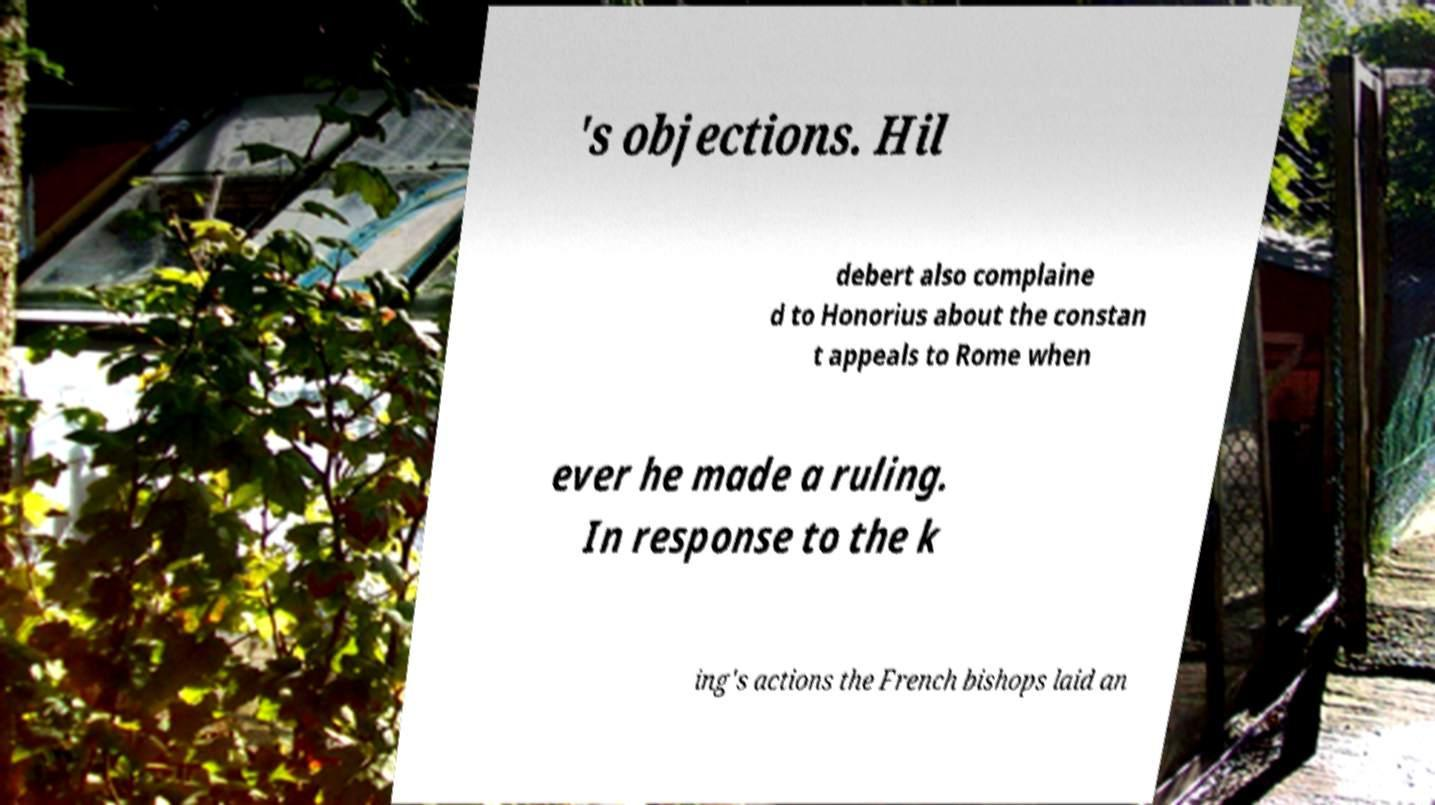Please identify and transcribe the text found in this image. 's objections. Hil debert also complaine d to Honorius about the constan t appeals to Rome when ever he made a ruling. In response to the k ing's actions the French bishops laid an 